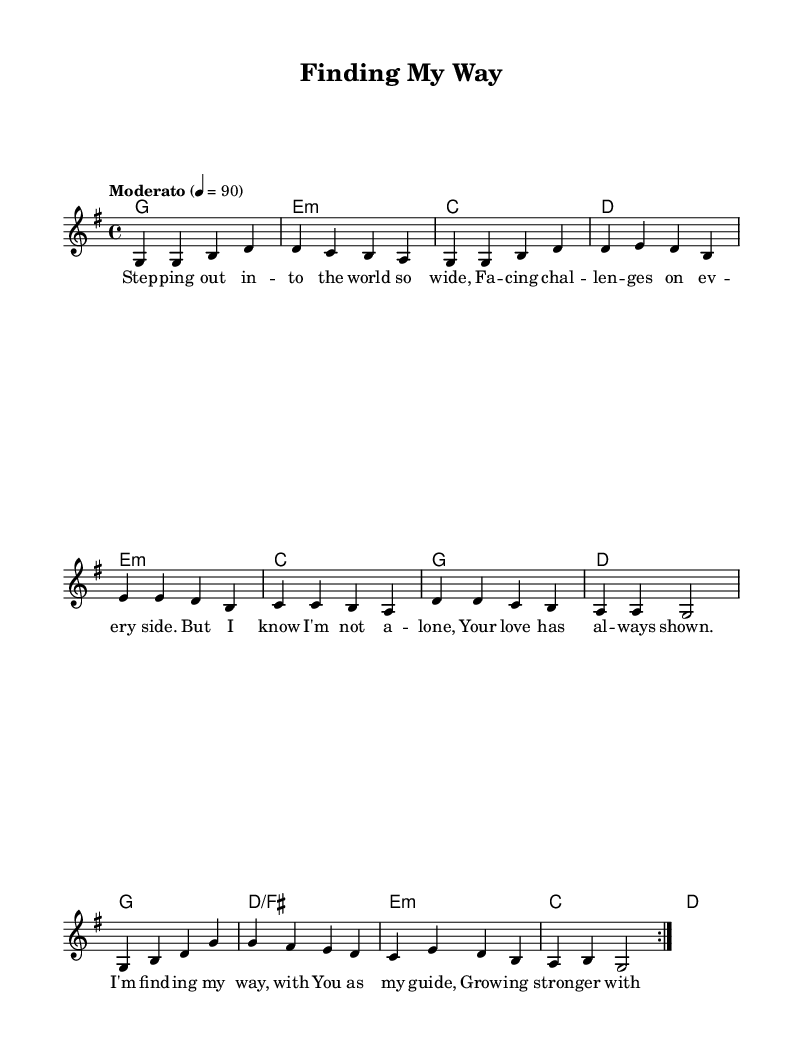What is the key signature of this music? The key signature is G major, which has one sharp (F#). This can be identified from the initial part of the score that indicates the key signature before the main melody begins.
Answer: G major What is the time signature of the piece? The time signature is 4/4, meaning there are four beats per measure and the quarter note receives one beat. This is indicated at the beginning of the score in the time signature marking.
Answer: 4/4 What is the tempo marking for this piece? The tempo marking is "Moderato" which indicates a moderate pace for the piece. This is noted above the staff in the tempo indication line.
Answer: Moderato How many total measures are there in the melody? There are 16 measures in the melody. This can be counted by looking at the number of complete phrases indicated by the vertical bar lines in the melody section.
Answer: 16 What is the first chord listed in the harmonies? The first chord in the harmonies is G major, indicated by the "g1" chord symbol at the beginning of the harmony section. This identifies the chord being played as the first in the series.
Answer: G major Which lyrical theme is primarily addressed in this ballad? The primary lyrical theme is about guidance and support in the journey of life, highlighting a personal connection and reliance on faith. This can be inferred from the context and specific lines in the lyrics that discuss growth and finding one's way with a guiding presence.
Answer: Guidance What mood does the song convey based on its lyrics? The mood conveyed by the lyrics is hopeful and uplifting, emphasizing strength in faith and companionship through life's challenges. This is derived from the repeated phrases about growing stronger and having a guiding love.
Answer: Hopeful 